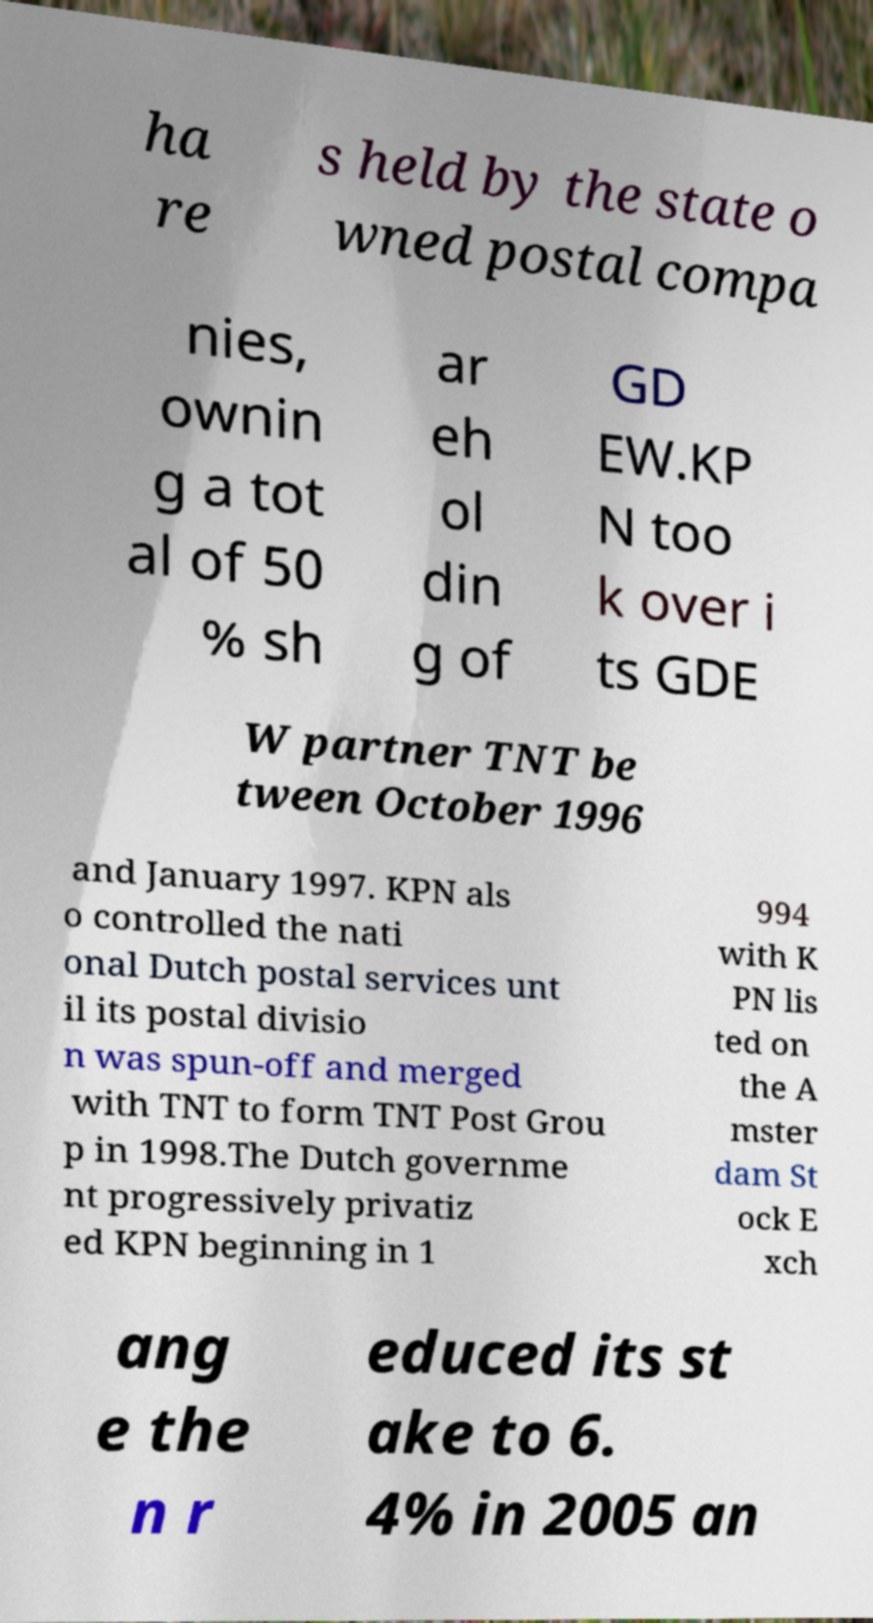Could you extract and type out the text from this image? ha re s held by the state o wned postal compa nies, ownin g a tot al of 50 % sh ar eh ol din g of GD EW.KP N too k over i ts GDE W partner TNT be tween October 1996 and January 1997. KPN als o controlled the nati onal Dutch postal services unt il its postal divisio n was spun-off and merged with TNT to form TNT Post Grou p in 1998.The Dutch governme nt progressively privatiz ed KPN beginning in 1 994 with K PN lis ted on the A mster dam St ock E xch ang e the n r educed its st ake to 6. 4% in 2005 an 